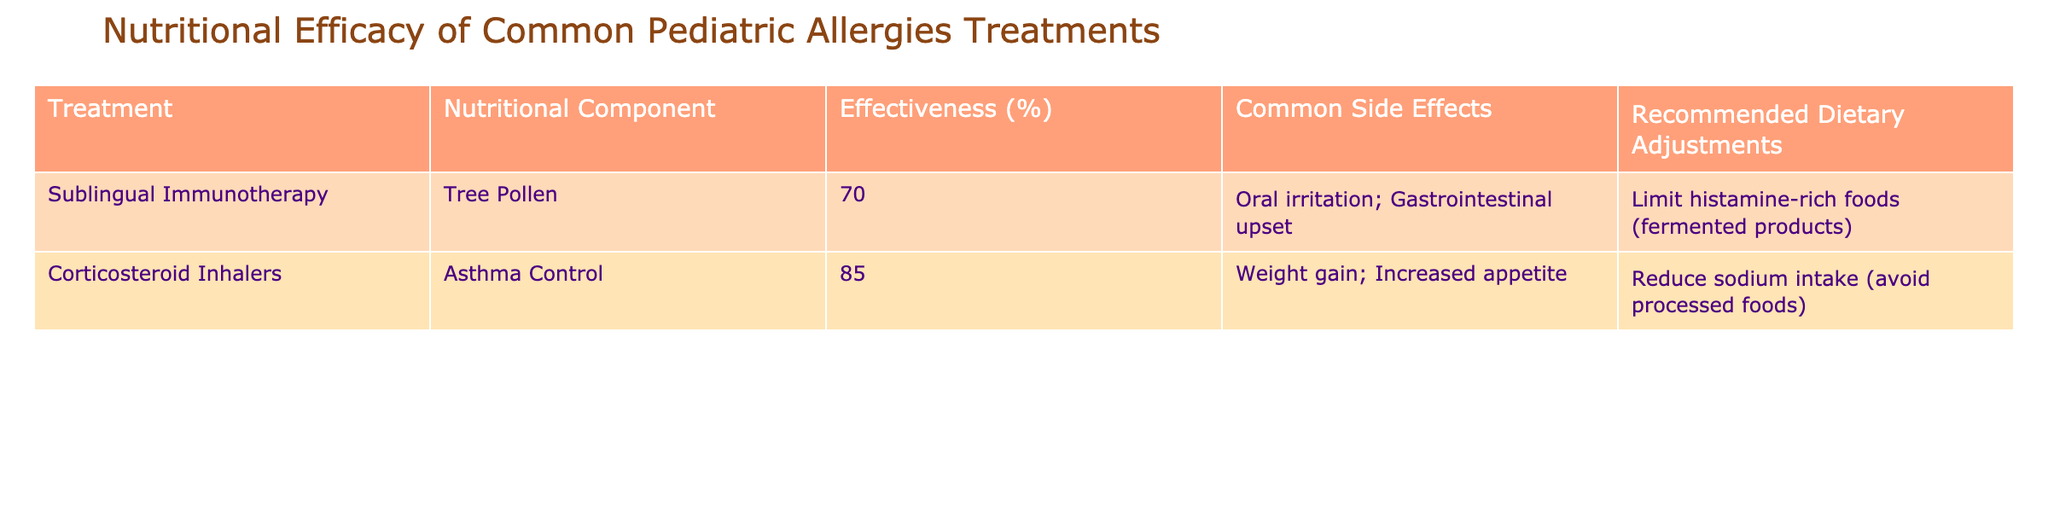What is the effectiveness percentage of Sublingual Immunotherapy for Tree Pollen? The table shows that the effectiveness percentage of Sublingual Immunotherapy for Tree Pollen is listed as 70%.
Answer: 70% What are the common side effects of Corticosteroid Inhalers? The table indicates the common side effects of Corticosteroid Inhalers are weight gain and increased appetite.
Answer: Weight gain; Increased appetite What is the recommended dietary adjustment for those undergoing Sublingual Immunotherapy? According to the table, the recommended dietary adjustment for Sublingual Immunotherapy is to limit histamine-rich foods, specifically fermented products.
Answer: Limit histamine-rich foods (fermented products) Which treatment has a higher effectiveness percentage, Sublingual Immunotherapy or Corticosteroid Inhalers? The effectiveness of Sublingual Immunotherapy is 70%, while that of Corticosteroid Inhalers is 85%. Since 85% is greater than 70%, Corticosteroid Inhalers are more effective.
Answer: Corticosteroid Inhalers What is the difference in effectiveness between the two treatments? The effectiveness of Corticosteroid Inhalers is 85% and that of Sublingual Immunotherapy is 70%. The difference is 85% - 70% = 15%.
Answer: 15% Are there any common side effects associated with Sublingual Immunotherapy? The table lists oral irritation and gastrointestinal upset as common side effects of Sublingual Immunotherapy, making the answer yes.
Answer: Yes What percentage of effectiveness is required for a treatment to be more effective than Sublingual Immunotherapy? Since Sublingual Immunotherapy has an effectiveness percentage of 70%, any treatment effectiveness over 70% would be considered more effective.
Answer: Over 70% Is it necessary to reduce sodium intake while using Sublingual Immunotherapy? The table does not recommend a reduction in sodium intake for Sublingual Immunotherapy. It specifically mentions dietary adjustments related to histamine-rich foods.
Answer: No If a child is using a treatment with an effectiveness of 85%, what might be a common side effect they should be aware of? Since 85% effectiveness corresponds to Corticosteroid Inhalers, the common side effects include weight gain and increased appetite.
Answer: Weight gain; Increased appetite Which treatment would you recommend based on higher effectiveness? Evaluating effectiveness, Corticosteroid Inhalers at 85% are recommended over Sublingual Immunotherapy at 70%.
Answer: Corticosteroid Inhalers 